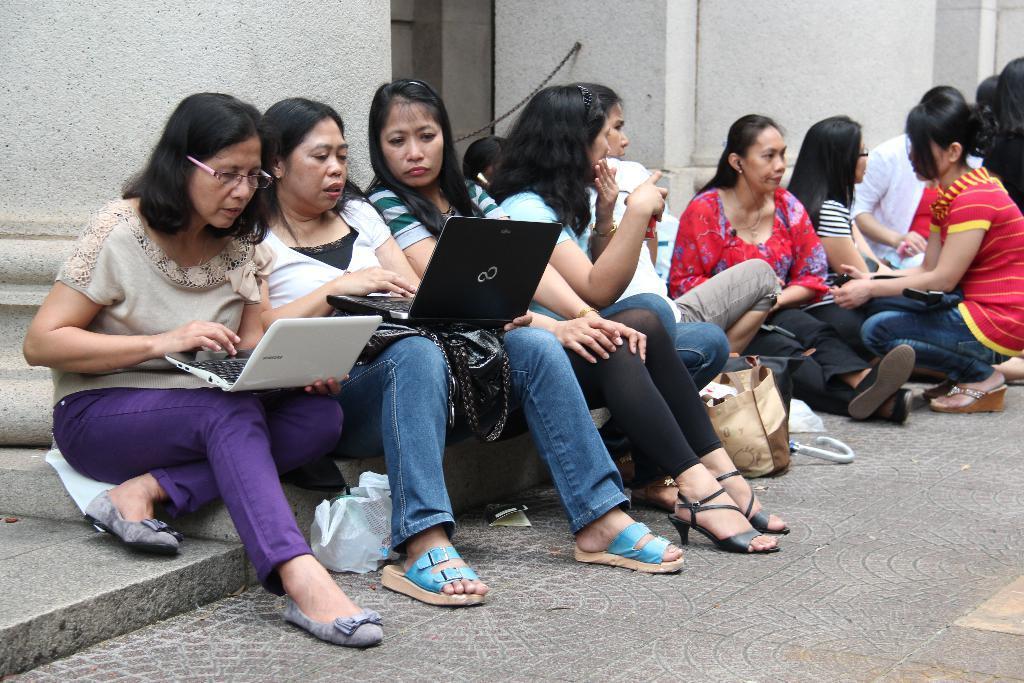Describe this image in one or two sentences. There are group of women sitting. Among them two women are holding laptops. This is the bag, which is placed on the floor. These are the pillars. This looks like an iron chain, which is black in color. 